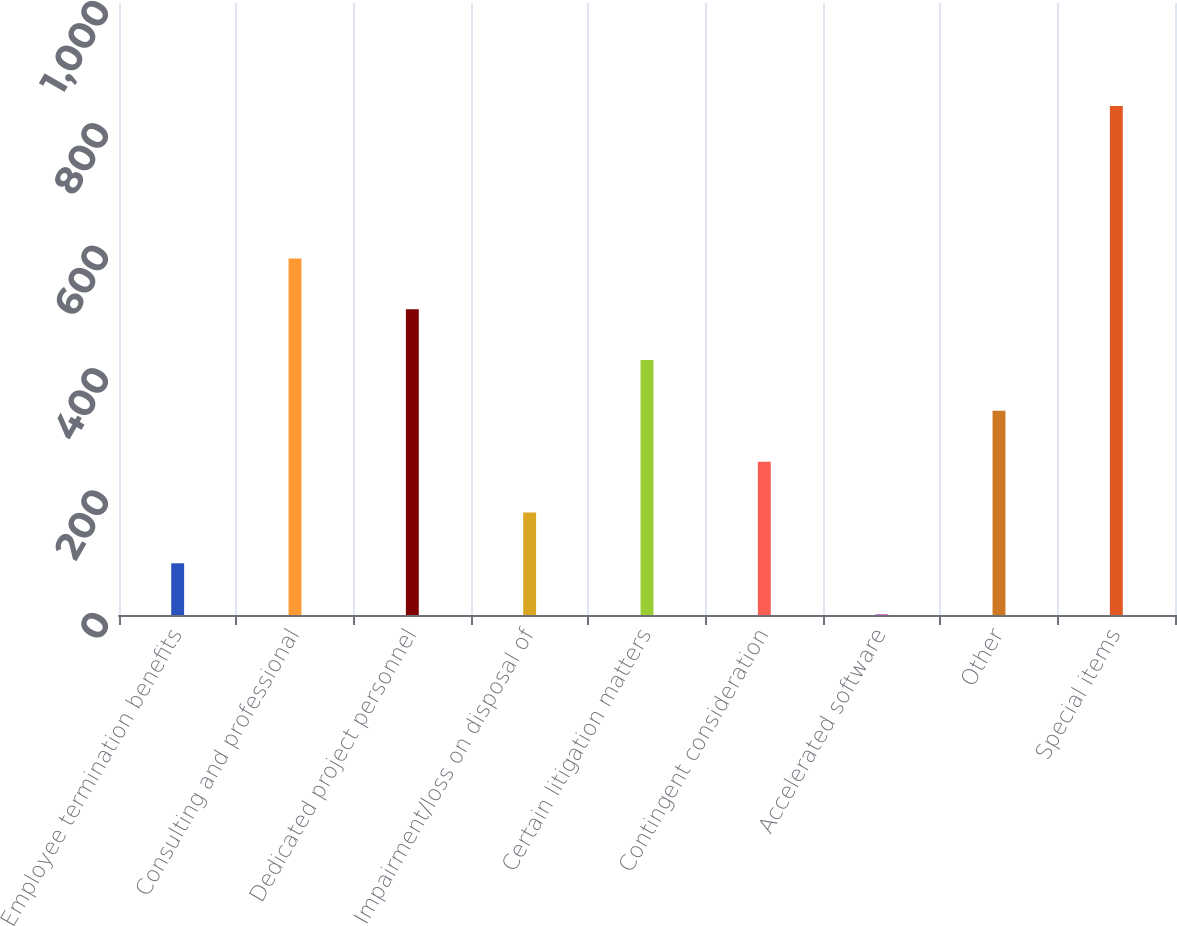Convert chart to OTSL. <chart><loc_0><loc_0><loc_500><loc_500><bar_chart><fcel>Employee termination benefits<fcel>Consulting and professional<fcel>Dedicated project personnel<fcel>Impairment/loss on disposal of<fcel>Certain litigation matters<fcel>Contingent consideration<fcel>Accelerated software<fcel>Other<fcel>Special items<nl><fcel>84.53<fcel>582.71<fcel>499.68<fcel>167.56<fcel>416.65<fcel>250.59<fcel>1.5<fcel>333.62<fcel>831.8<nl></chart> 